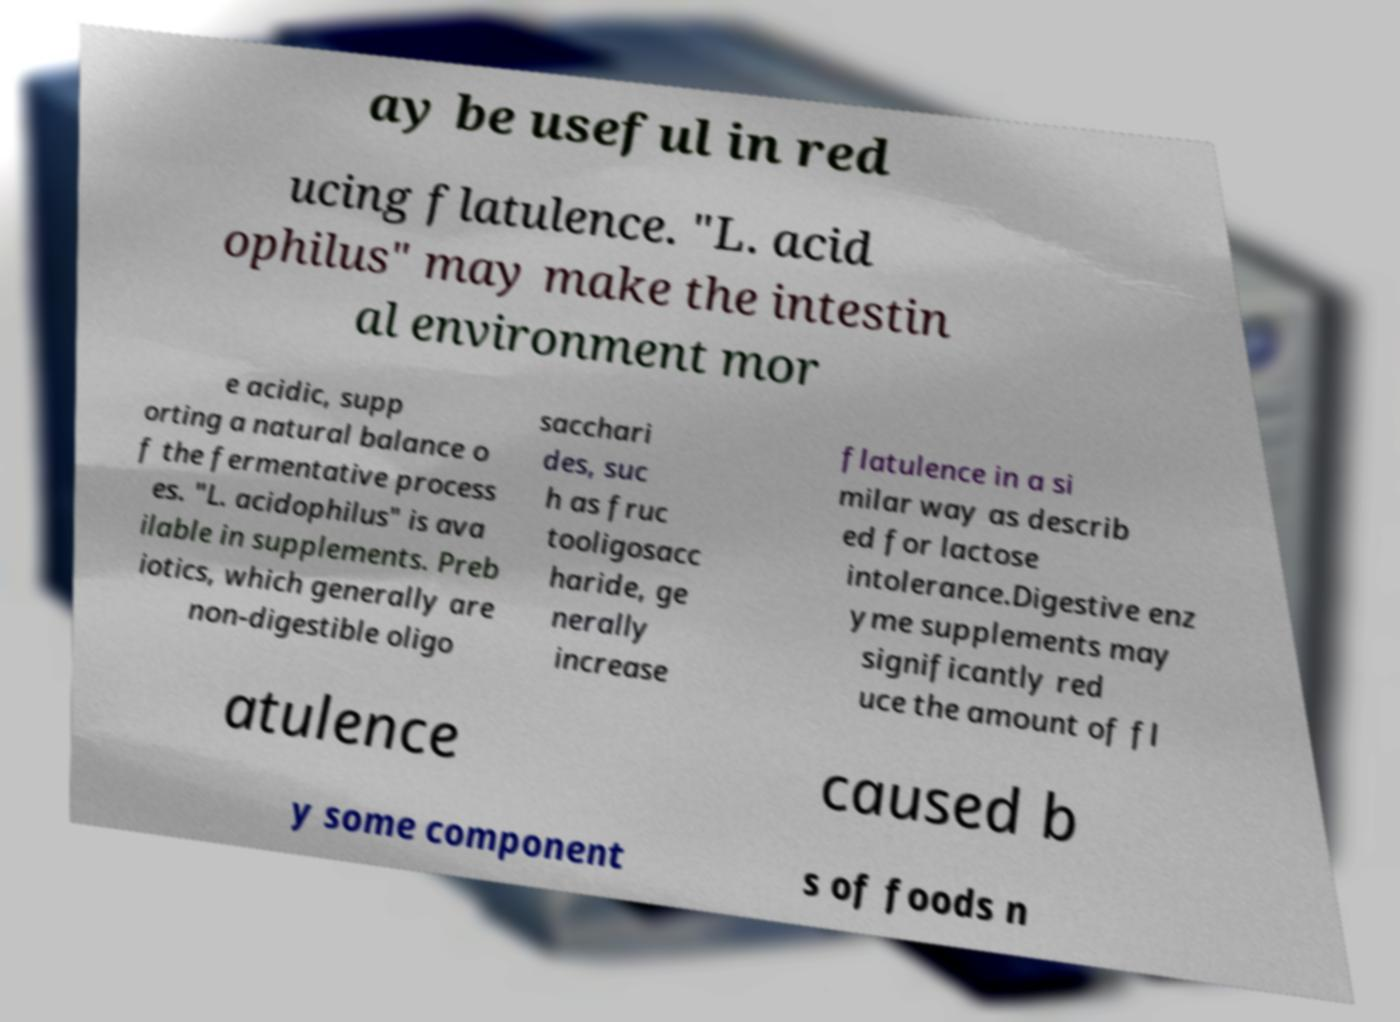There's text embedded in this image that I need extracted. Can you transcribe it verbatim? ay be useful in red ucing flatulence. "L. acid ophilus" may make the intestin al environment mor e acidic, supp orting a natural balance o f the fermentative process es. "L. acidophilus" is ava ilable in supplements. Preb iotics, which generally are non-digestible oligo sacchari des, suc h as fruc tooligosacc haride, ge nerally increase flatulence in a si milar way as describ ed for lactose intolerance.Digestive enz yme supplements may significantly red uce the amount of fl atulence caused b y some component s of foods n 